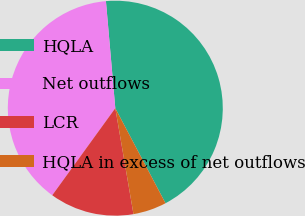Convert chart. <chart><loc_0><loc_0><loc_500><loc_500><pie_chart><fcel>HQLA<fcel>Net outflows<fcel>LCR<fcel>HQLA in excess of net outflows<nl><fcel>43.66%<fcel>38.64%<fcel>12.68%<fcel>5.03%<nl></chart> 